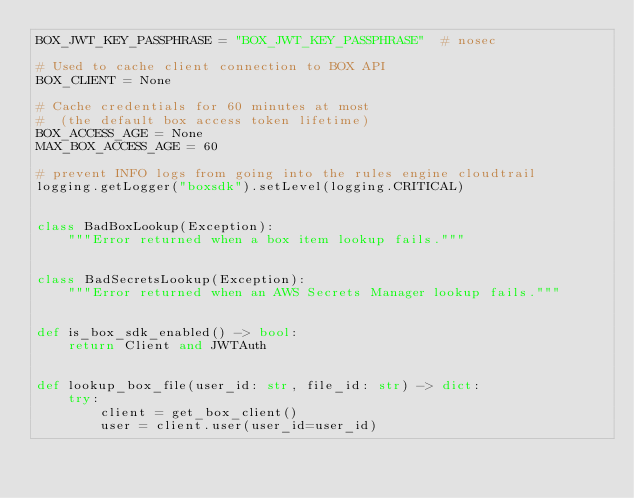Convert code to text. <code><loc_0><loc_0><loc_500><loc_500><_Python_>BOX_JWT_KEY_PASSPHRASE = "BOX_JWT_KEY_PASSPHRASE"  # nosec

# Used to cache client connection to BOX API
BOX_CLIENT = None

# Cache credentials for 60 minutes at most
#  (the default box access token lifetime)
BOX_ACCESS_AGE = None
MAX_BOX_ACCESS_AGE = 60

# prevent INFO logs from going into the rules engine cloudtrail
logging.getLogger("boxsdk").setLevel(logging.CRITICAL)


class BadBoxLookup(Exception):
    """Error returned when a box item lookup fails."""


class BadSecretsLookup(Exception):
    """Error returned when an AWS Secrets Manager lookup fails."""


def is_box_sdk_enabled() -> bool:
    return Client and JWTAuth


def lookup_box_file(user_id: str, file_id: str) -> dict:
    try:
        client = get_box_client()
        user = client.user(user_id=user_id)</code> 